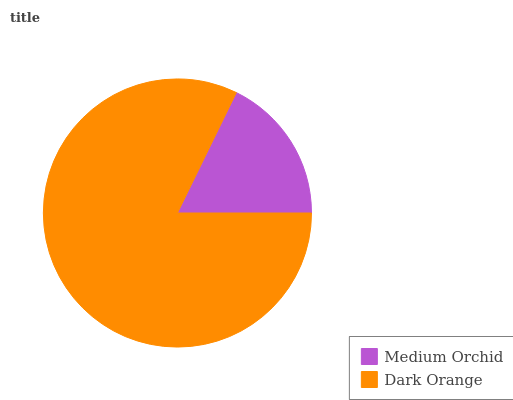Is Medium Orchid the minimum?
Answer yes or no. Yes. Is Dark Orange the maximum?
Answer yes or no. Yes. Is Dark Orange the minimum?
Answer yes or no. No. Is Dark Orange greater than Medium Orchid?
Answer yes or no. Yes. Is Medium Orchid less than Dark Orange?
Answer yes or no. Yes. Is Medium Orchid greater than Dark Orange?
Answer yes or no. No. Is Dark Orange less than Medium Orchid?
Answer yes or no. No. Is Dark Orange the high median?
Answer yes or no. Yes. Is Medium Orchid the low median?
Answer yes or no. Yes. Is Medium Orchid the high median?
Answer yes or no. No. Is Dark Orange the low median?
Answer yes or no. No. 